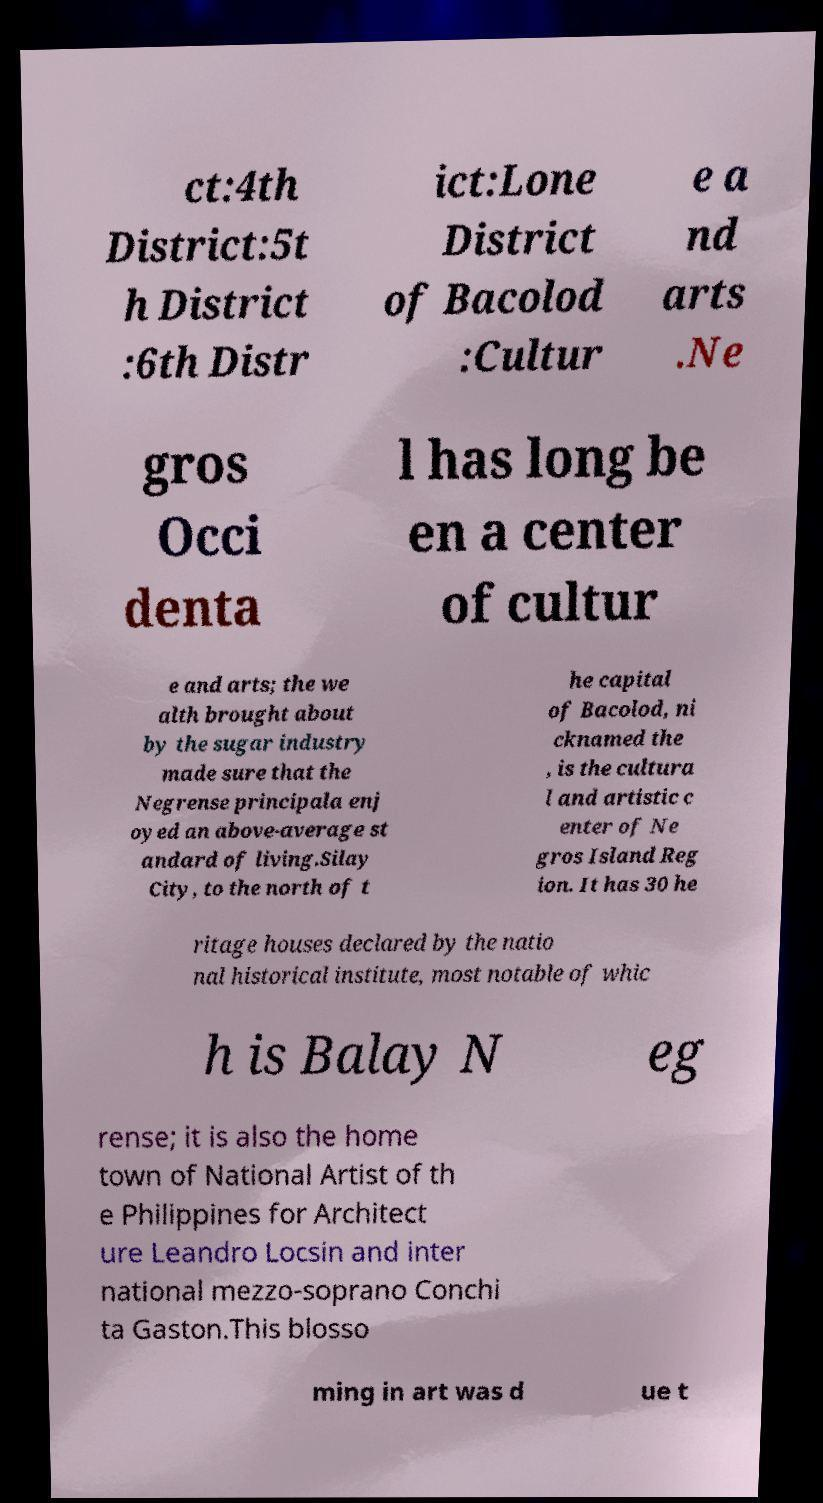Please identify and transcribe the text found in this image. ct:4th District:5t h District :6th Distr ict:Lone District of Bacolod :Cultur e a nd arts .Ne gros Occi denta l has long be en a center of cultur e and arts; the we alth brought about by the sugar industry made sure that the Negrense principala enj oyed an above-average st andard of living.Silay City, to the north of t he capital of Bacolod, ni cknamed the , is the cultura l and artistic c enter of Ne gros Island Reg ion. It has 30 he ritage houses declared by the natio nal historical institute, most notable of whic h is Balay N eg rense; it is also the home town of National Artist of th e Philippines for Architect ure Leandro Locsin and inter national mezzo-soprano Conchi ta Gaston.This blosso ming in art was d ue t 